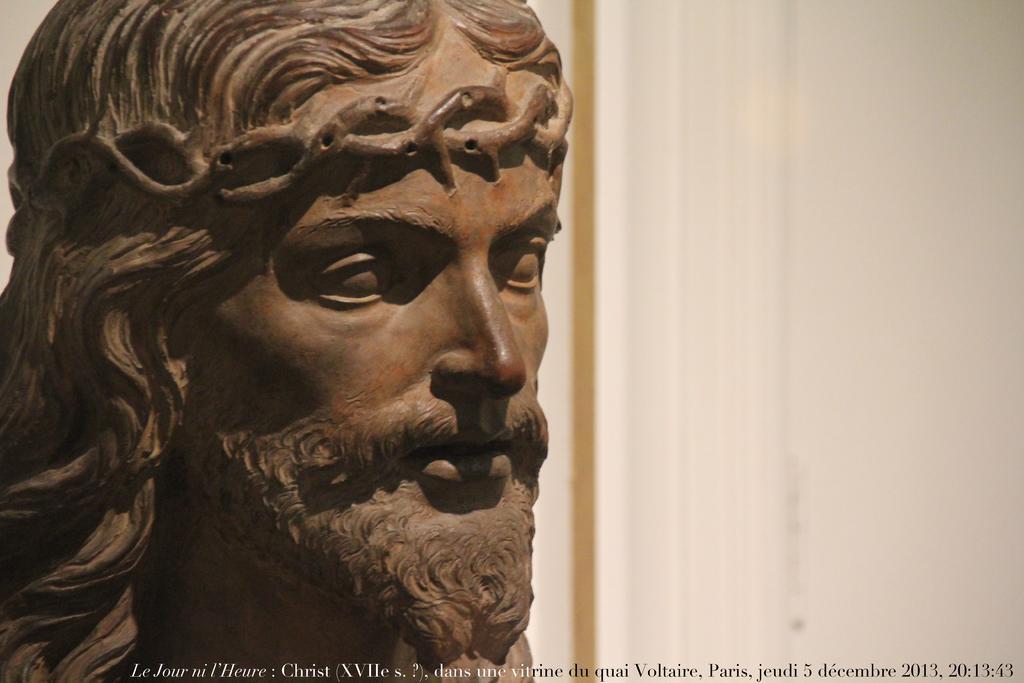Could you give a brief overview of what you see in this image? This image consists of a sculpture. On the right, we can see a wall. The sculpture is in brown color. 